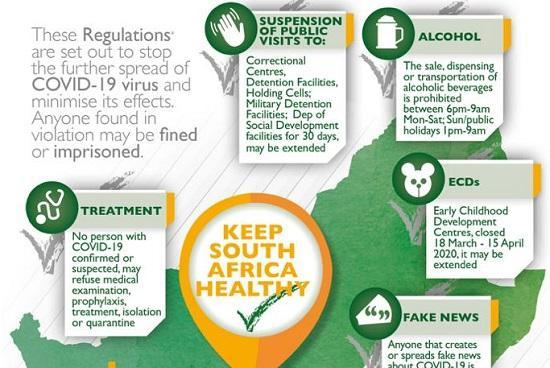Which is the third place listed in the infographic to be not visited to?
Answer the question with a short phrase. Holding cells Which is the fifth place listed in the infographic to be not visited to? Dep of Social Development facilities 